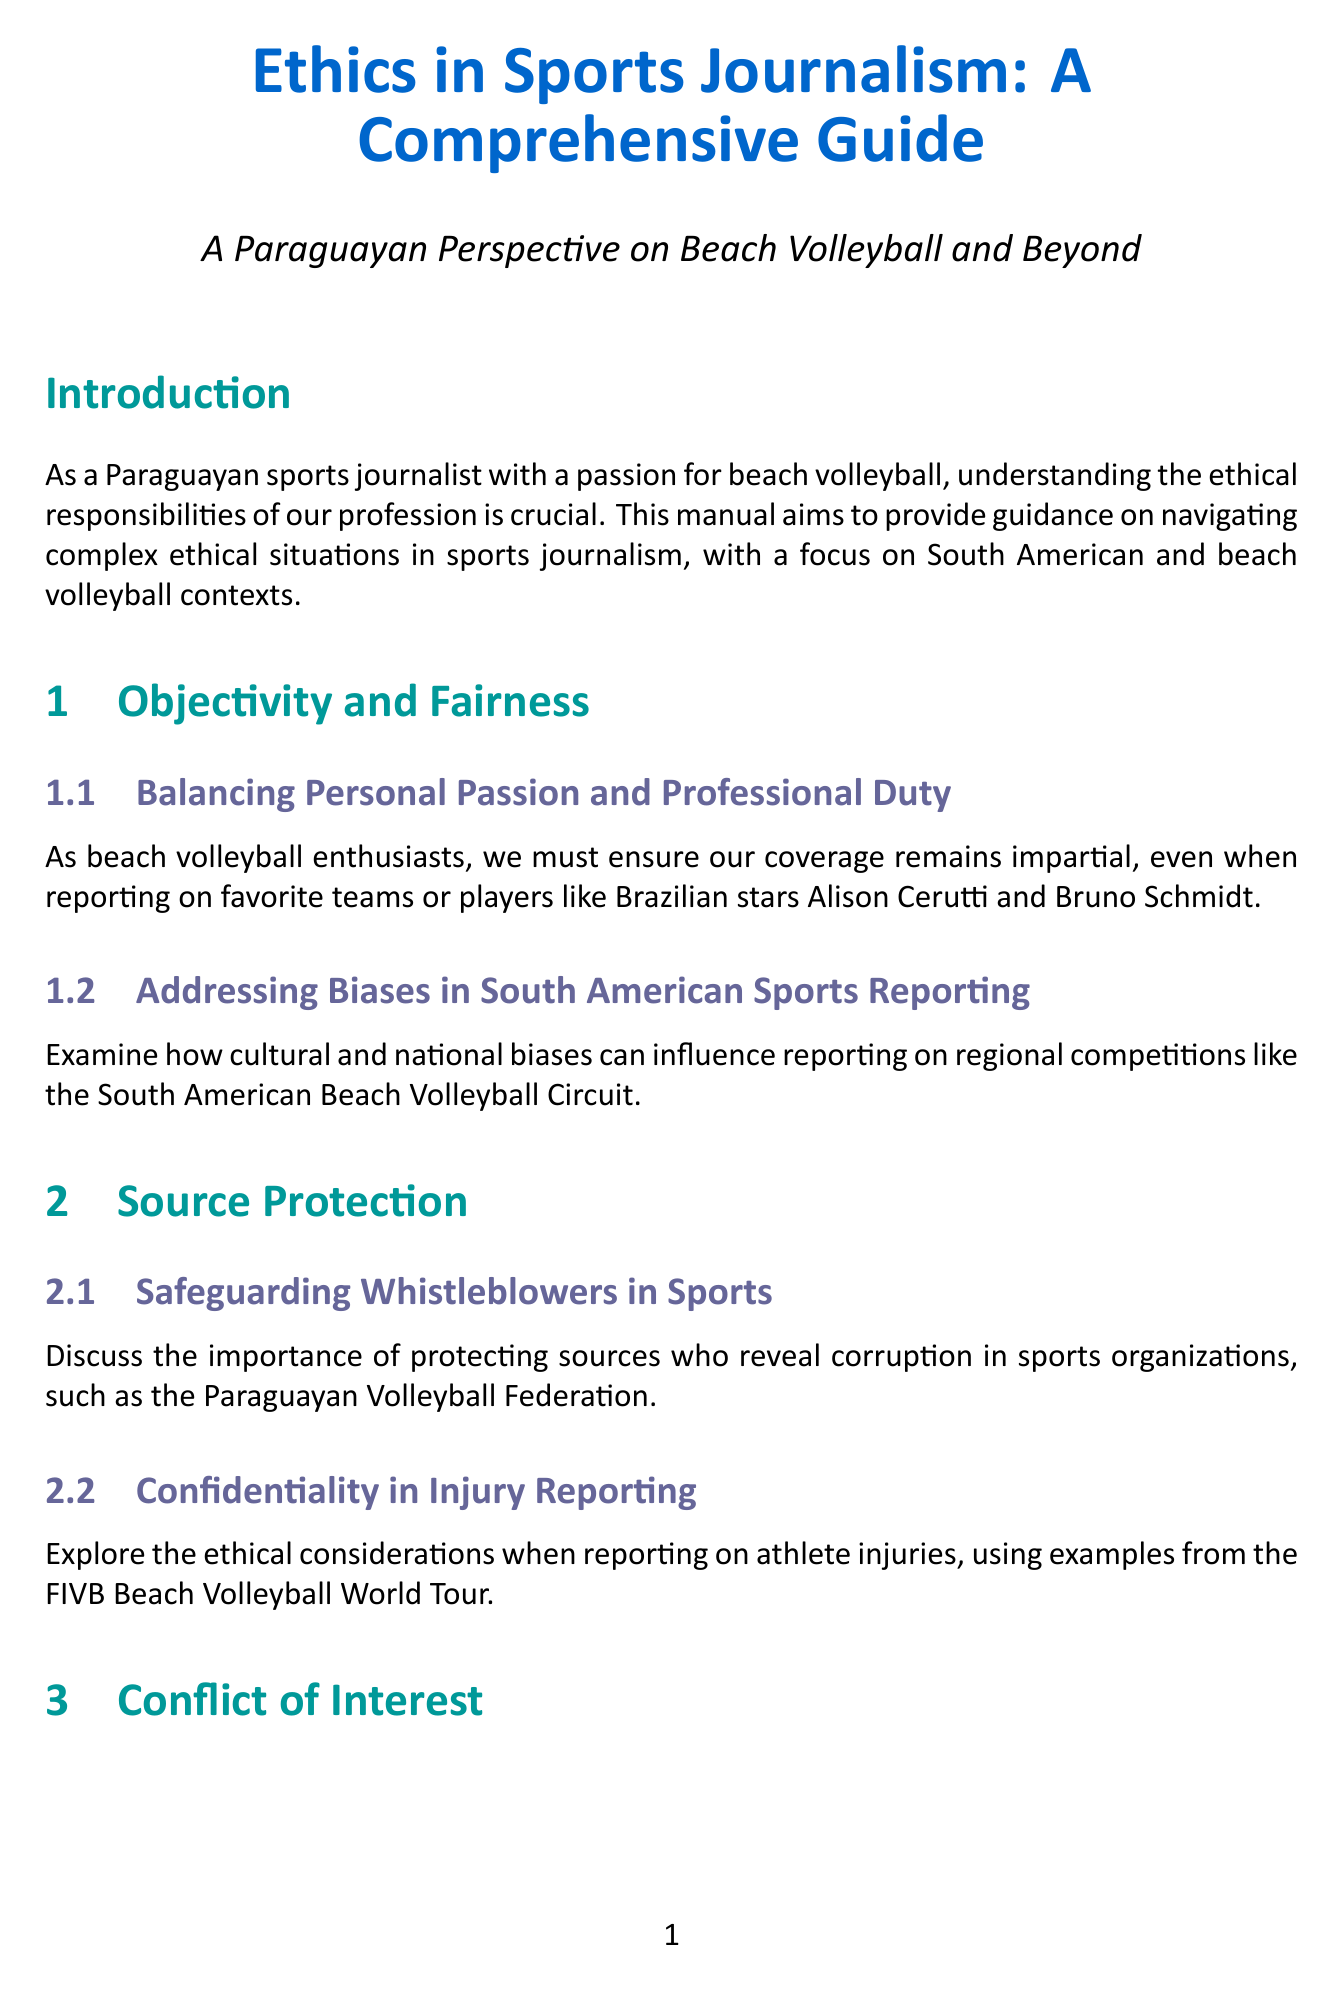what is the title of the manual? The title is prominently displayed at the beginning of the document, indicating the focus on sports journalism ethics.
Answer: Ethics in Sports Journalism: A Comprehensive Guide what section addresses source protection? The document is structured into sections, and the relevant section on source protection is clearly labeled.
Answer: Source Protection who is mentioned as a prominent beach volleyball player in a personal relationship example? This information is found in the section discussing the maintenance of professionalism while covering athletes.
Answer: Roger Battilana what year did the doping allegations case study occur? The document specifies the date of events discussed in case studies, which can be found under the case studies section.
Answer: 2015 what type of ethical considerations are explored in the digital age section? The document outlines various aspects regarding ethics in modern reporting practices, categorized under a specific section.
Answer: Social Media Ethics what is the main focus of the introduction section? The introduction summarizes the purpose of the manual and the importance of ethics in sports journalism, specifically in a cultural context.
Answer: Ethical responsibilities how many case studies are presented in the manual? The document itemizes the content of the case studies in a list format, allowing for quick reference to their quantity.
Answer: Three what is one challenge mentioned in the conflict of interest section? The document discusses specific ethical challenges in the context of relationships and sponsorships within sports journalism practices.
Answer: Sponsorship and Editorial Independence which event is associated with the 2019 South American Beach Games controversy case study? The document references a particular event that faced coverage dilemmas, providing a framework for analysis in the case study.
Answer: Argentina and Brazil 